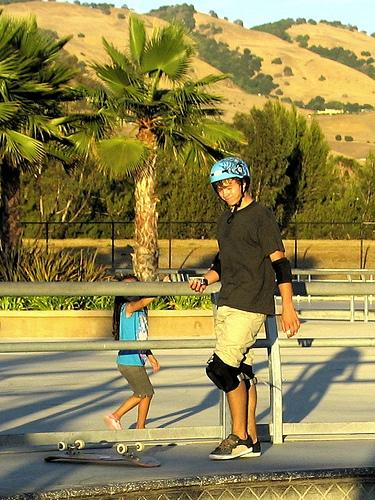What kind of palm tree is in the center of this photo? tropical 